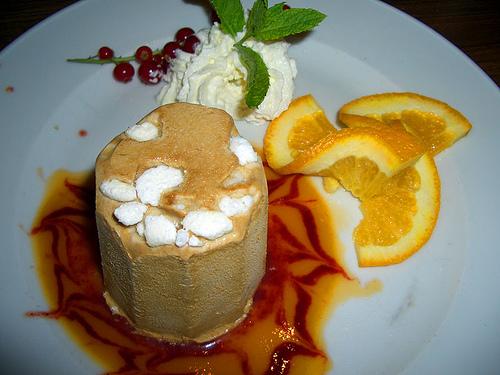What fruit is on the plate?
Short answer required. Orange. Is this a full meal?
Keep it brief. No. What are the red objects on the plate?
Answer briefly. Berries. What kind of seeds are those?
Be succinct. Pomegranate. What race is the person holding the food?
Short answer required. White. What is brown in the image?
Concise answer only. Ice cream. What is are the slices made of?
Give a very brief answer. Orange. What kind of dessert is this?
Concise answer only. Ice cream. 